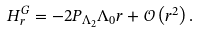Convert formula to latex. <formula><loc_0><loc_0><loc_500><loc_500>H _ { r } ^ { G } = - 2 P _ { \Lambda _ { 2 } } \Lambda _ { 0 } r + \mathcal { O } \left ( r ^ { 2 } \right ) .</formula> 